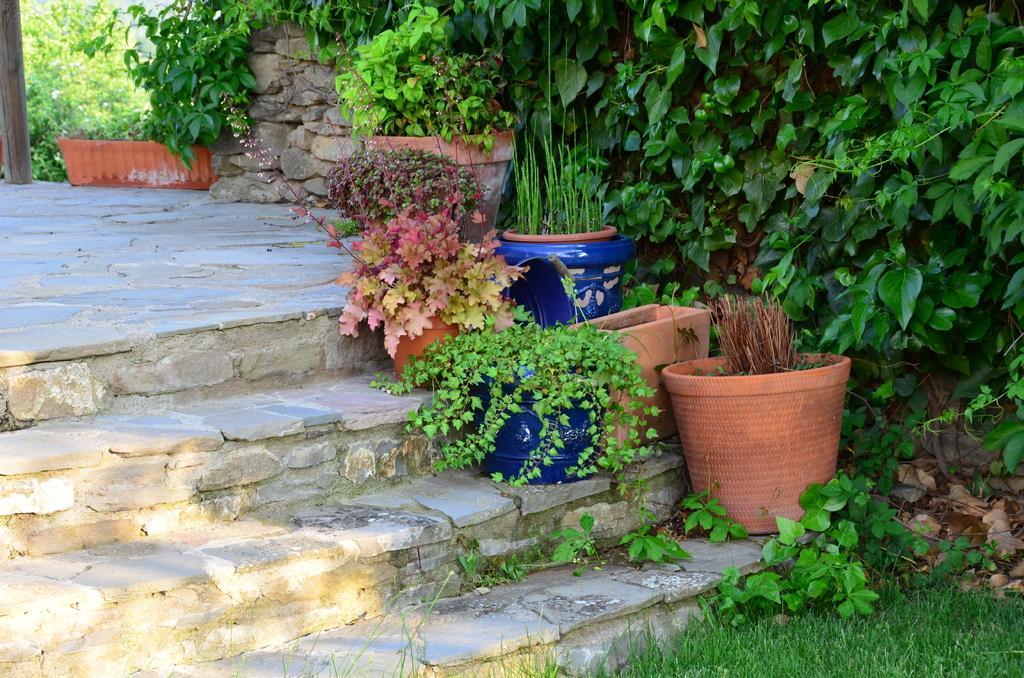Can you describe this image briefly? In the foreground of the picture there are flower pots, plants, staircase and grass. On the top there are trees, wall and plants. 